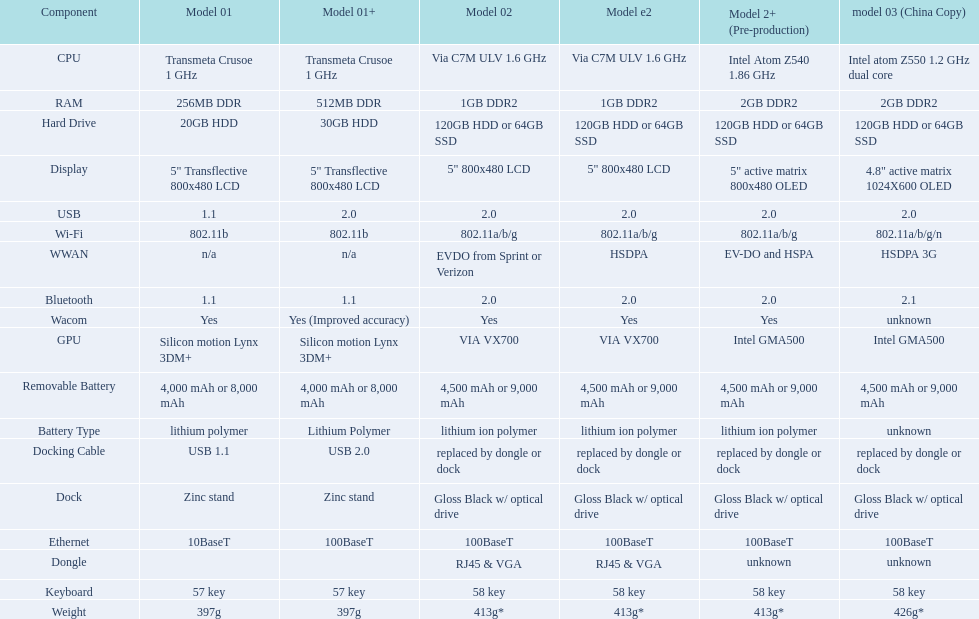What is the next highest hard drive available after the 30gb model? 64GB SSD. 